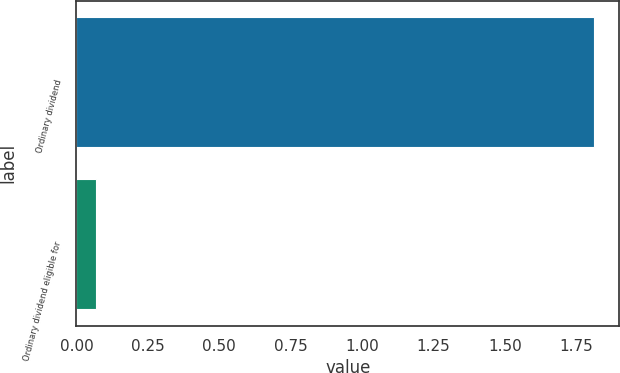Convert chart to OTSL. <chart><loc_0><loc_0><loc_500><loc_500><bar_chart><fcel>Ordinary dividend<fcel>Ordinary dividend eligible for<nl><fcel>1.81<fcel>0.07<nl></chart> 